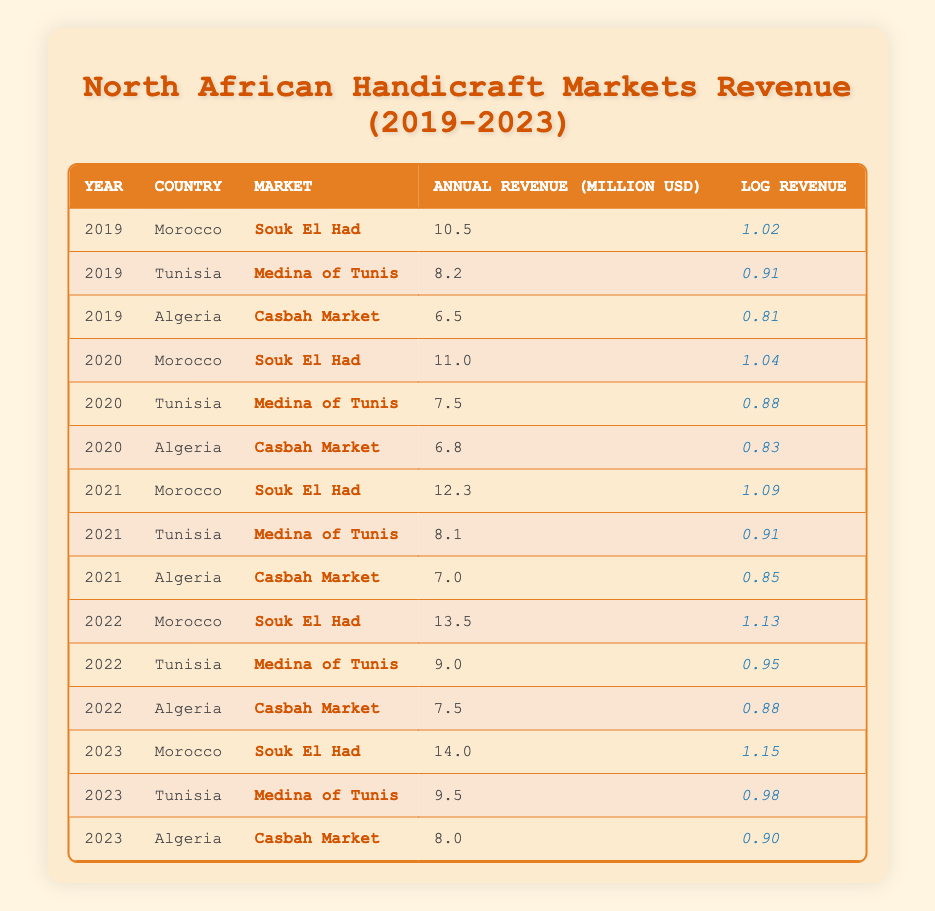What was the annual revenue of Souk El Had in 2021? The table shows that in 2021, the annual revenue of Souk El Had in Morocco was recorded at 12.3 million USD.
Answer: 12.3 million USD Which market had the highest annual revenue in 2023? In 2023, the Souk El Had market in Morocco had the highest revenue at 14.0 million USD, compared to 9.5 million USD at the Medina of Tunis and 8.0 million USD at the Casbah Market.
Answer: Souk El Had What is the total annual revenue of the Medina of Tunis from 2019 to 2023? The annual revenues for the Medina of Tunis are: 8.2 (2019) + 7.5 (2020) + 8.1 (2021) + 9.0 (2022) + 9.5 (2023) = 42.3 million USD.
Answer: 42.3 million USD Did the annual revenue of Casbah Market decline from 2021 to 2022? The table shows that the annual revenue of Casbah Market was 7.0 million USD in 2021 and rose to 7.5 million USD in 2022. Therefore, it did not decline.
Answer: No What is the average annual revenue of Souk El Had from 2019 to 2023? The annual revenues for Souk El Had over these years are 10.5 (2019), 11.0 (2020), 12.3 (2021), 13.5 (2022), and 14.0 (2023). Their sum is 10.5 + 11.0 + 12.3 + 13.5 + 14.0 = 61.3 million USD; dividing by 5 gives an average of 61.3 / 5 = 12.26 million USD.
Answer: 12.26 million USD Which country's market generated the lowest annual revenue in 2020? In 2020, the annual revenues were Morocco's Souk El Had at 11.0 million USD, Tunisia's Medina of Tunis at 7.5 million USD, and Algeria's Casbah Market at 6.8 million USD. The Casbah Market had the lowest revenue.
Answer: Algeria's Casbah Market Has the annual revenue of handicraft markets in Tunisia generally increased over the years? To determine this, we look at the annual revenues: 8.2 (2019), 7.5 (2020), 8.1 (2021), 9.0 (2022), and 9.5 (2023). The revenues fluctuated first, decreasing from 2019 to 2020 but then increasing each following year, indicating a general upward trend.
Answer: Yes What is the difference in annual revenue of Souk El Had between 2019 and 2023? The annual revenue for Souk El Had was 10.5 million USD in 2019 and 14.0 million USD in 2023. The difference is calculated as 14.0 - 10.5 = 3.5 million USD.
Answer: 3.5 million USD 